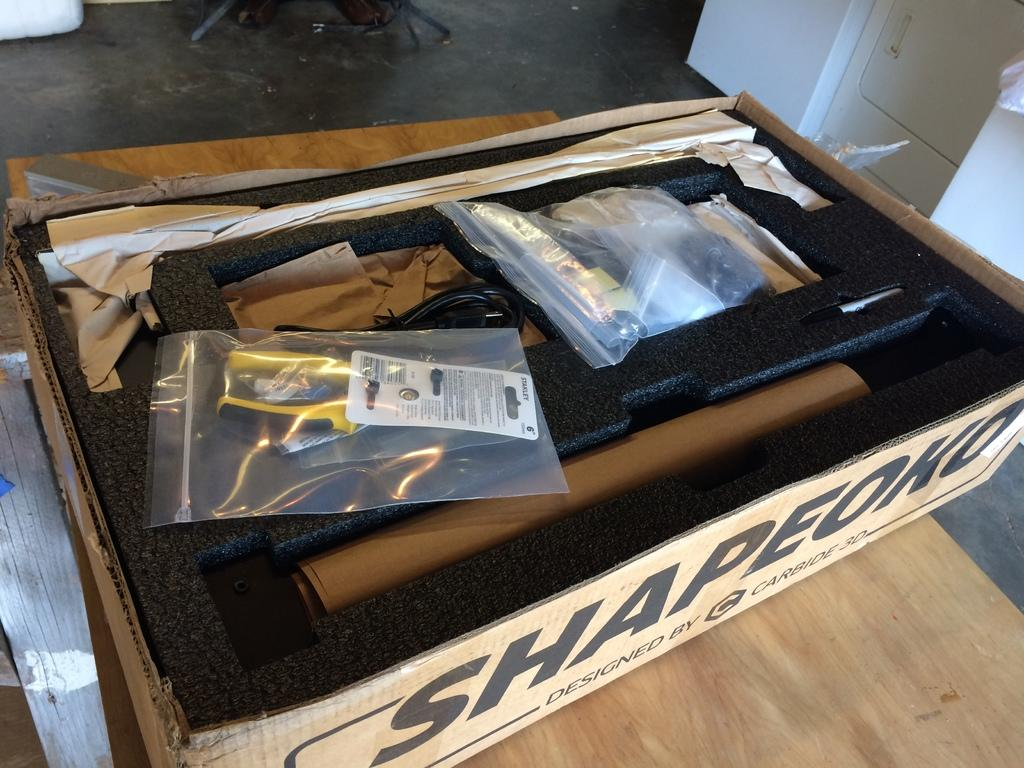What is the main object in the image? There is a carton box in the image. What is inside the carton box? The carton box contains objects. On what surface is the carton box placed? The carton box is placed on a wooden surface. What else can be seen in the image besides the carton box? There are objects visible on the floor at the top of the image. Can you tell me how many cars are parked in the image? There are no cars present in the image; it features a carton box on a wooden surface with objects visible on the floor. 